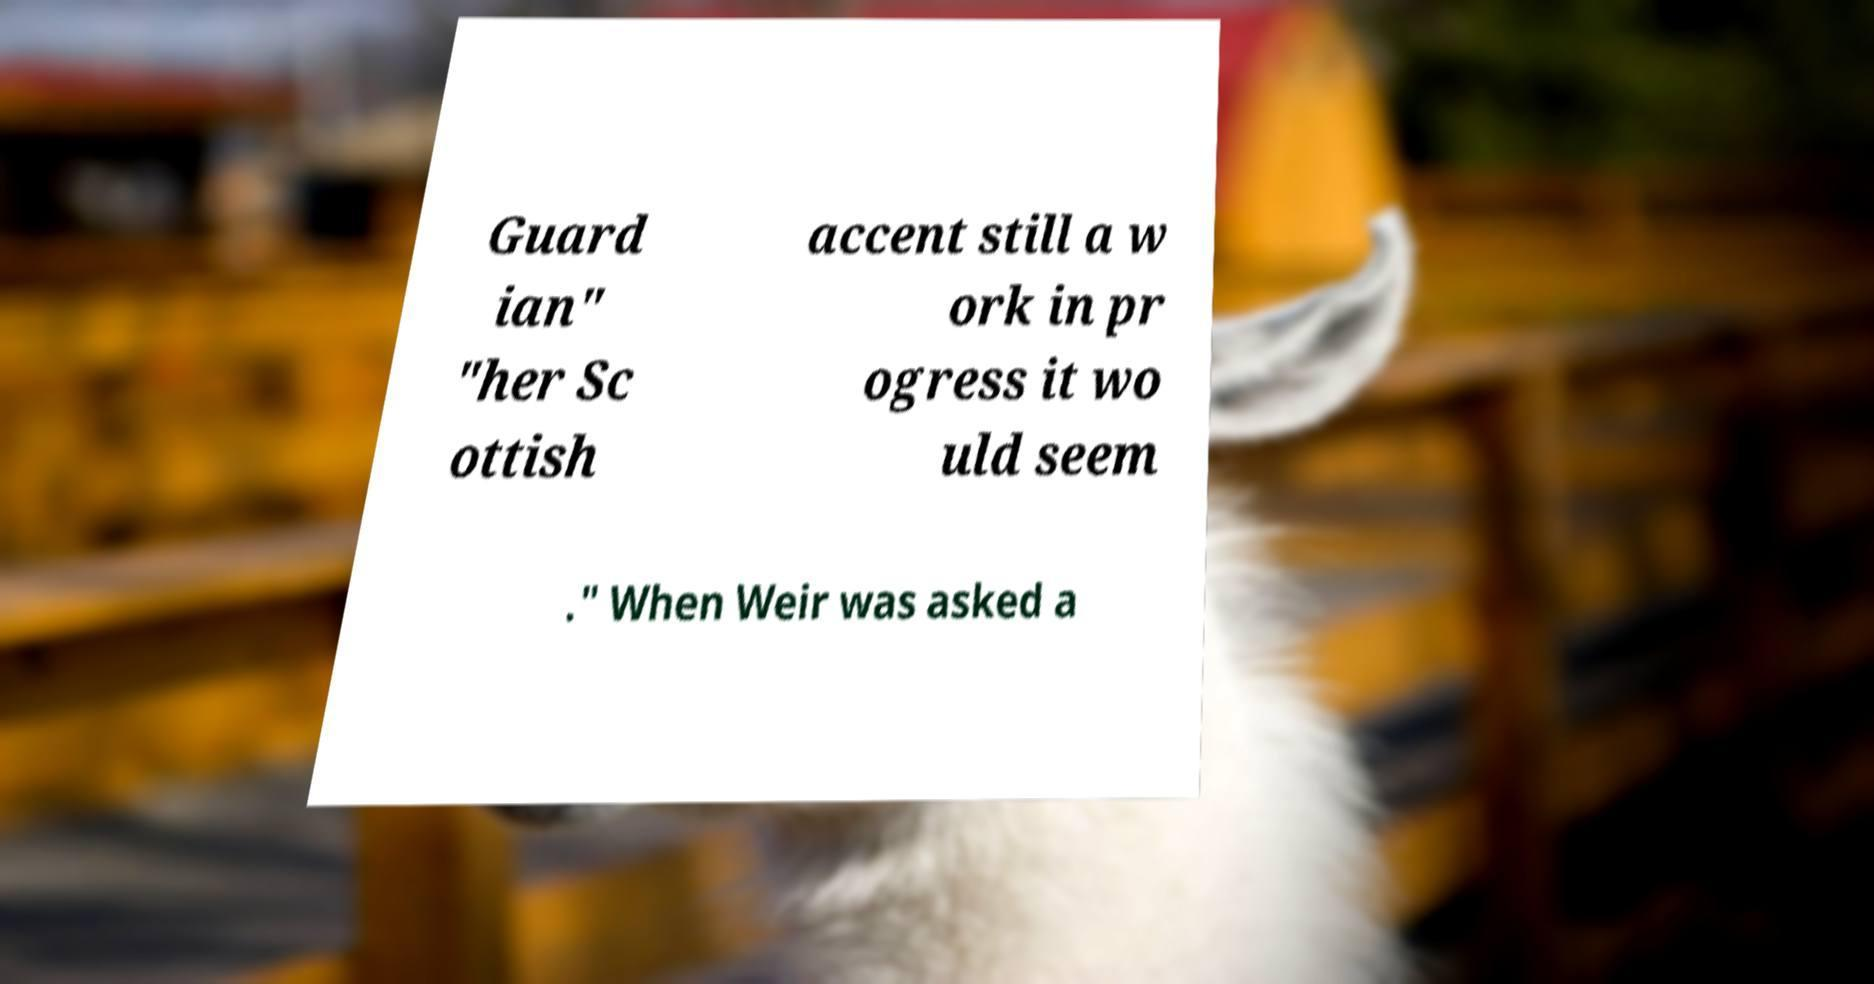For documentation purposes, I need the text within this image transcribed. Could you provide that? Guard ian" "her Sc ottish accent still a w ork in pr ogress it wo uld seem ." When Weir was asked a 